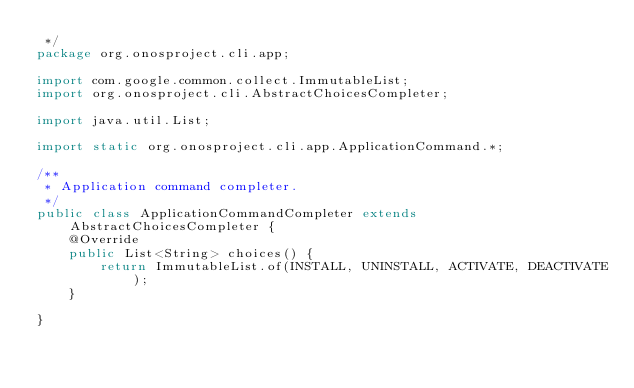Convert code to text. <code><loc_0><loc_0><loc_500><loc_500><_Java_> */
package org.onosproject.cli.app;

import com.google.common.collect.ImmutableList;
import org.onosproject.cli.AbstractChoicesCompleter;

import java.util.List;

import static org.onosproject.cli.app.ApplicationCommand.*;

/**
 * Application command completer.
 */
public class ApplicationCommandCompleter extends AbstractChoicesCompleter {
    @Override
    public List<String> choices() {
        return ImmutableList.of(INSTALL, UNINSTALL, ACTIVATE, DEACTIVATE);
    }

}
</code> 